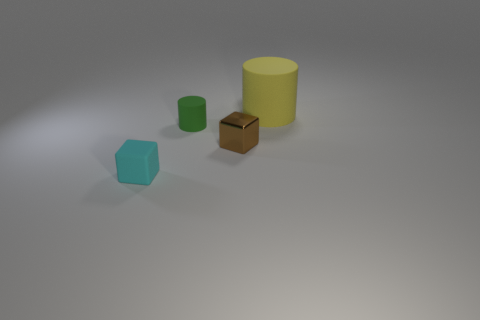Do the cube that is to the right of the green rubber cylinder and the matte cylinder that is in front of the big object have the same size?
Provide a short and direct response. Yes. The big object that is behind the tiny cyan matte cube has what shape?
Your answer should be very brief. Cylinder. There is a cylinder that is to the left of the matte cylinder to the right of the tiny brown shiny thing; what is it made of?
Offer a terse response. Rubber. Are there any small things that have the same color as the big matte thing?
Make the answer very short. No. There is a brown thing; is its size the same as the thing that is in front of the small brown shiny thing?
Provide a short and direct response. Yes. What number of big rubber objects are in front of the cube that is to the right of the small cube left of the tiny green matte thing?
Offer a very short reply. 0. There is a green rubber cylinder; what number of blocks are to the right of it?
Make the answer very short. 1. What color is the big matte object on the right side of the rubber cylinder to the left of the big rubber cylinder?
Your answer should be compact. Yellow. What number of other things are there of the same material as the brown block
Offer a terse response. 0. Are there the same number of tiny cubes to the right of the small cyan thing and red metallic balls?
Keep it short and to the point. No. 